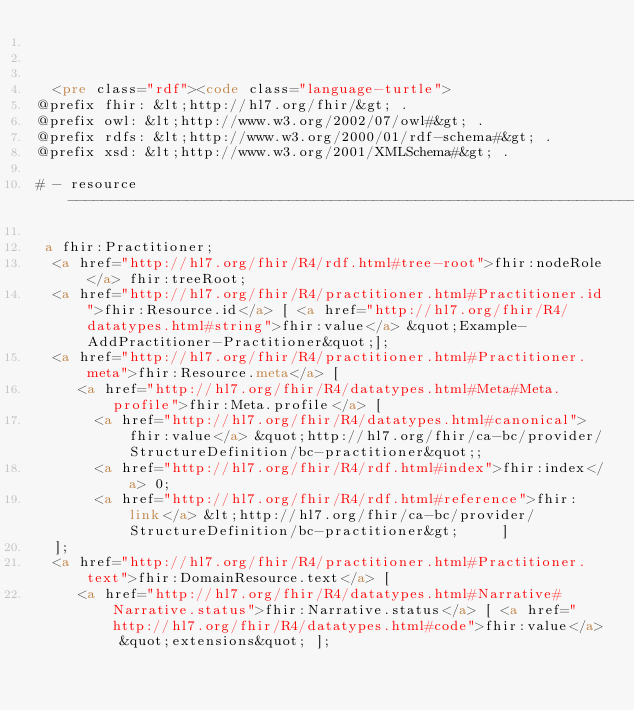Convert code to text. <code><loc_0><loc_0><loc_500><loc_500><_HTML_>


  <pre class="rdf"><code class="language-turtle">
@prefix fhir: &lt;http://hl7.org/fhir/&gt; .
@prefix owl: &lt;http://www.w3.org/2002/07/owl#&gt; .
@prefix rdfs: &lt;http://www.w3.org/2000/01/rdf-schema#&gt; .
@prefix xsd: &lt;http://www.w3.org/2001/XMLSchema#&gt; .

# - resource -------------------------------------------------------------------

 a fhir:Practitioner;
  <a href="http://hl7.org/fhir/R4/rdf.html#tree-root">fhir:nodeRole</a> fhir:treeRoot;
  <a href="http://hl7.org/fhir/R4/practitioner.html#Practitioner.id">fhir:Resource.id</a> [ <a href="http://hl7.org/fhir/R4/datatypes.html#string">fhir:value</a> &quot;Example-AddPractitioner-Practitioner&quot;];
  <a href="http://hl7.org/fhir/R4/practitioner.html#Practitioner.meta">fhir:Resource.meta</a> [
     <a href="http://hl7.org/fhir/R4/datatypes.html#Meta#Meta.profile">fhir:Meta.profile</a> [
       <a href="http://hl7.org/fhir/R4/datatypes.html#canonical">fhir:value</a> &quot;http://hl7.org/fhir/ca-bc/provider/StructureDefinition/bc-practitioner&quot;;
       <a href="http://hl7.org/fhir/R4/rdf.html#index">fhir:index</a> 0;
       <a href="http://hl7.org/fhir/R4/rdf.html#reference">fhir:link</a> &lt;http://hl7.org/fhir/ca-bc/provider/StructureDefinition/bc-practitioner&gt;     ]
  ];
  <a href="http://hl7.org/fhir/R4/practitioner.html#Practitioner.text">fhir:DomainResource.text</a> [
     <a href="http://hl7.org/fhir/R4/datatypes.html#Narrative#Narrative.status">fhir:Narrative.status</a> [ <a href="http://hl7.org/fhir/R4/datatypes.html#code">fhir:value</a> &quot;extensions&quot; ];</code> 